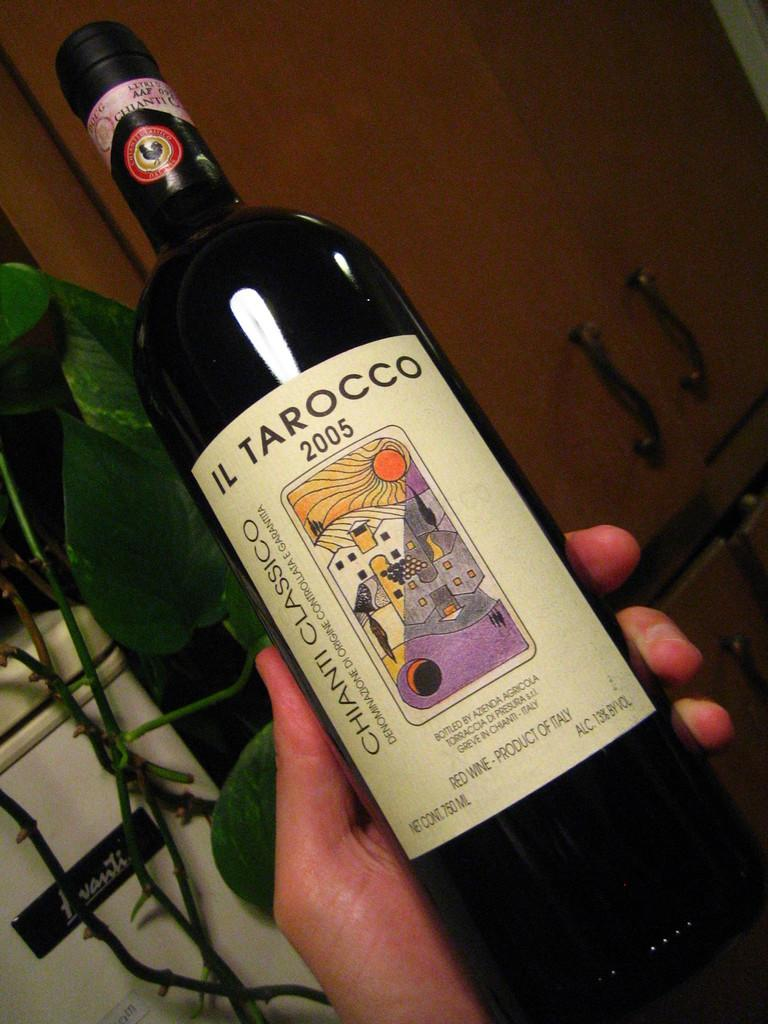<image>
Provide a brief description of the given image. a bottle of Il Tarocco 2005 Chianti classico wine 